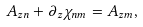Convert formula to latex. <formula><loc_0><loc_0><loc_500><loc_500>A _ { z n } + \partial _ { z } \chi _ { n m } = A _ { z m } ,</formula> 